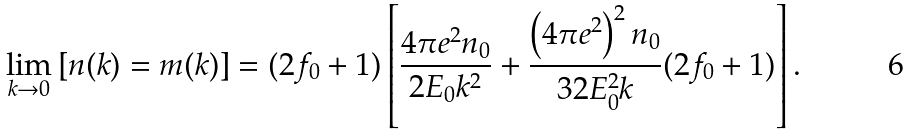Convert formula to latex. <formula><loc_0><loc_0><loc_500><loc_500>\lim _ { k \rightarrow 0 } \left [ n ( k ) = m ( k ) \right ] = ( 2 f _ { 0 } + 1 ) \left [ \frac { 4 \pi e ^ { 2 } n _ { 0 } } { 2 E _ { 0 } k ^ { 2 } } + \frac { \left ( 4 \pi e ^ { 2 } \right ) ^ { 2 } n _ { 0 } } { 3 2 E _ { 0 } ^ { 2 } k } ( 2 f _ { 0 } + 1 ) \right ] .</formula> 